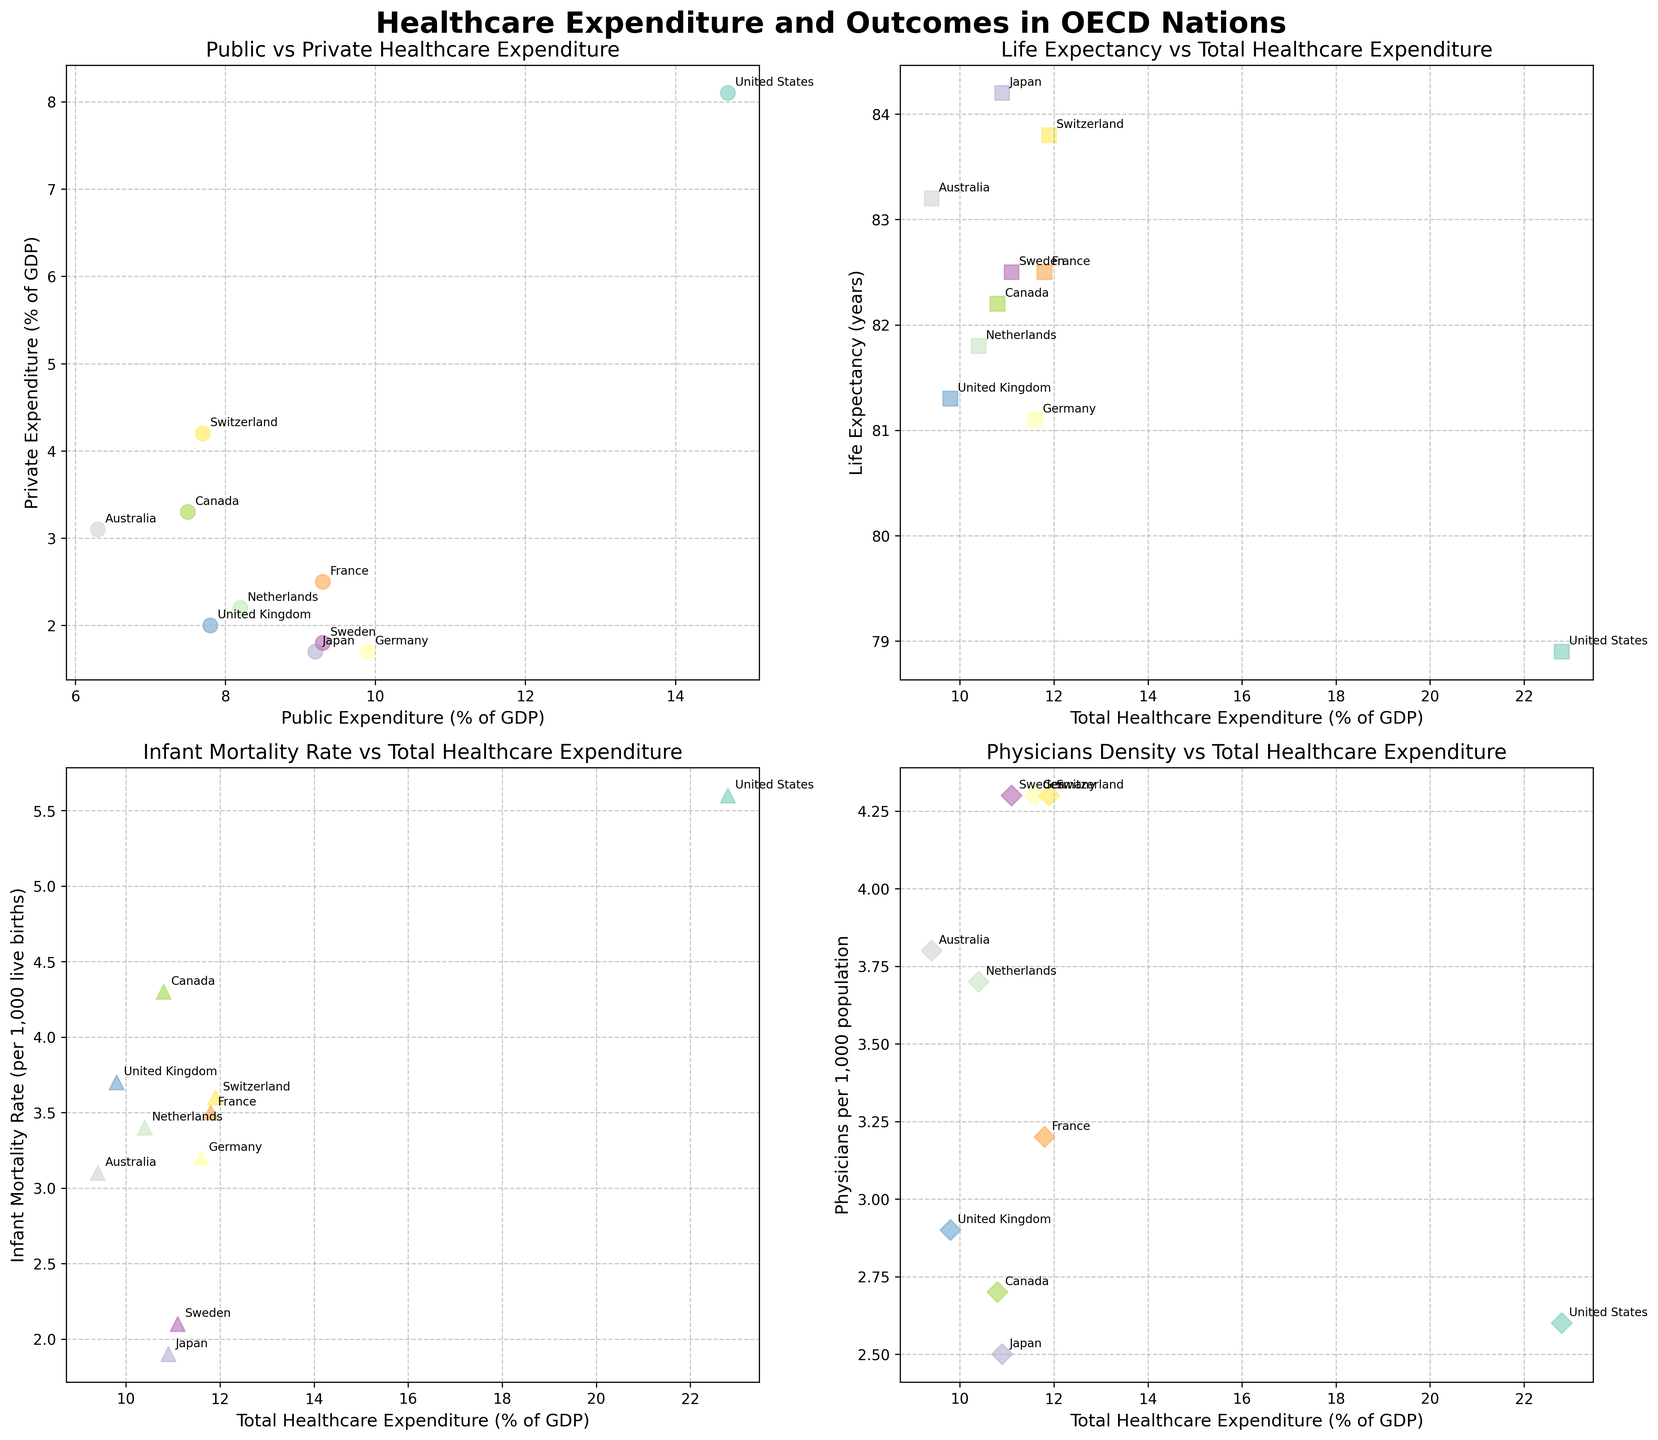What is the main title of the grid of subplots? The main title is located at the top center of the entire figure, written in bold, large font. It provides a brief description of what the figure is about. The title reads "Healthcare Expenditure and Outcomes in OECD Nations".
Answer: Healthcare Expenditure and Outcomes in OECD Nations Which nation has the highest public healthcare expenditure as a percentage of GDP? We need to look at the first subplot, "Public vs Private Healthcare Expenditure". The highest point on the x-axis represents the highest public healthcare expenditure. The United States is located at an x-axis value of 14.7, which is the highest.
Answer: United States How does life expectancy relate to total healthcare expenditure in the plot? In the second subplot titled "Life Expectancy vs Total Healthcare Expenditure", we observe the scatter plot where life expectancy (y-axis) and total healthcare expenditure (x-axis) are plotted. The general trend shows that countries with higher total healthcare expenditures tend to have higher life expectancies, as points tend to cluster upwards with increasing expenditure.
Answer: Higher expenditure generally leads to higher life expectancy Which country has the lowest infant mortality rate and what is its total healthcare expenditure? To determine this, look at the third subplot "Infant Mortality Rate vs Total Healthcare Expenditure". The lowest point on the y-axis indicates the lowest infant mortality rate. Japan is at the lowest point with an infant mortality rate of 1.9 and a total expenditure of around 10.9 % GDP (adding 9.2 public and 1.7 private).
Answer: Japan, 10.9% GDP Compare the public and private healthcare expenditures of Germany and the United States. Which country has a higher expenditure, and in what categories? In the first subplot "Public vs Private Healthcare Expenditure", locate data points for Germany and the United States. Germany has public 9.9% and private 1.7% of GDP. The United States has public 14.7% and private 8.1% of GDP. The United States has higher expenditures in both categories.
Answer: United States, in both public and private categories What is the relationship between physicians per 1000 population and total healthcare expenditure? The fourth subplot, "Physicians Density vs Total Healthcare Expenditure", shows a scatter plot with physicians per 1000 on the y-axis and total expenditure on the x-axis. Although there is variability, the general trend suggests that a higher expenditure supports a higher density of physicians, as most countries with higher expenditure have more physicians per 1000 population.
Answer: Higher expenditure generally supports more physicians Which country has the most physicians per 1000 population, and what is its total healthcare expenditure? Look at the fourth subplot "Physicians Density vs Total Healthcare Expenditure". The highest point on the y-axis represents the country with the most physicians per 1000 population. Germany and Switzerland are the highest countries with 4.3 physicians per 1000. Germany has a total expenditure of about 11.6% (9.9 public + 1.7 private) and Switzerland has 11.9% (7.7 public + 4.2 private).
Answer: Germany and Switzerland, 11.6% and 11.9% GDP respectively 